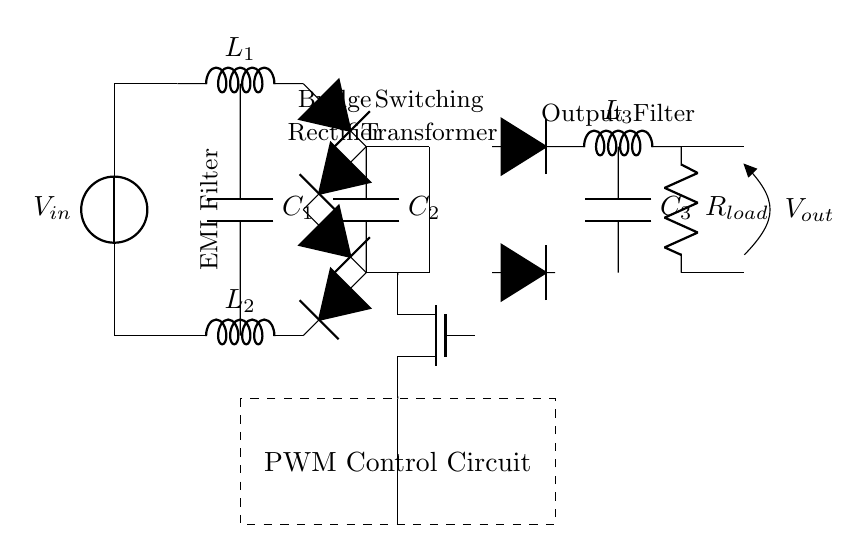what is the input voltage of the circuit? The circuit diagram indicates a voltage source labeled as Vin, which represents the input voltage. Since no specific value is provided within the diagram, it is referred to as Vin.
Answer: Vin what are the components used in the EMI filter? The EMI filter consists of an inductor labeled L1 and another inductor labeled L2, along with a capacitor labeled C1. These components are visually identifiable in the circuit labeled "EMI Filter".
Answer: L1, L2, C1 how many diodes are in the bridge rectifier? The bridge rectifier in the circuit contains four diodes, indicated by the four symbols in a bridge configuration, which convert AC voltage to DC voltage.
Answer: four diodes what is the primary function of the PWM control circuit? The primary function of the PWM control circuit is to provide pulse-width modulation to the switching MOSFET, controlling its on/off timing to regulate the output voltage. This regulation helps in maintaining efficient power supply to the load.
Answer: pulse-width modulation what is the purpose of the smoothing capacitor? The smoothing capacitor, labeled C2 in the circuit, is used to reduce voltage ripple from the rectified DC output, providing a more stable DC voltage to subsequent stages in the power supply circuit.
Answer: to reduce voltage ripple what is the role of Rload in this circuit? Rload, labeled at the output, represents the load resistance that characterizes the device or circuit the power supply is providing power to, allowing current to flow and the circuit to operate as a complete system.
Answer: load resistance what type of circuit is this? This is a high-efficiency switched-mode power supply circuit designed specifically for data center servers, characterized by its use of switching elements and associated control circuitry to deliver efficient power conversion.
Answer: switched-mode power supply circuit 